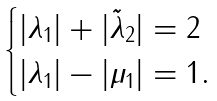<formula> <loc_0><loc_0><loc_500><loc_500>\begin{cases} | \lambda _ { 1 } | + | \tilde { \lambda } _ { 2 } | = 2 \\ | \lambda _ { 1 } | - | \mu _ { 1 } | = 1 . \end{cases}</formula> 